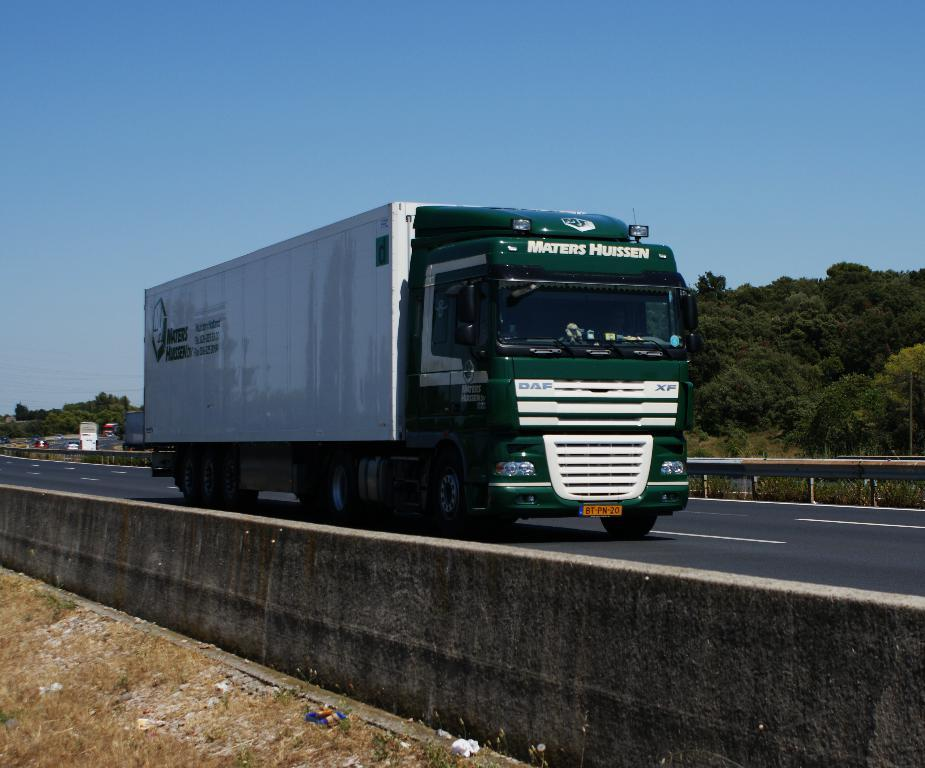What is the main subject of the image? There is a vehicle in the image. Where is the vehicle located? The vehicle is on the road. What can be seen in the background of the image? There are many trees behind the vehicle. What type of glue is being used to hold the trees together in the image? There is no glue or indication of trees being held together in the image; it simply shows a vehicle on the road with trees in the background. 